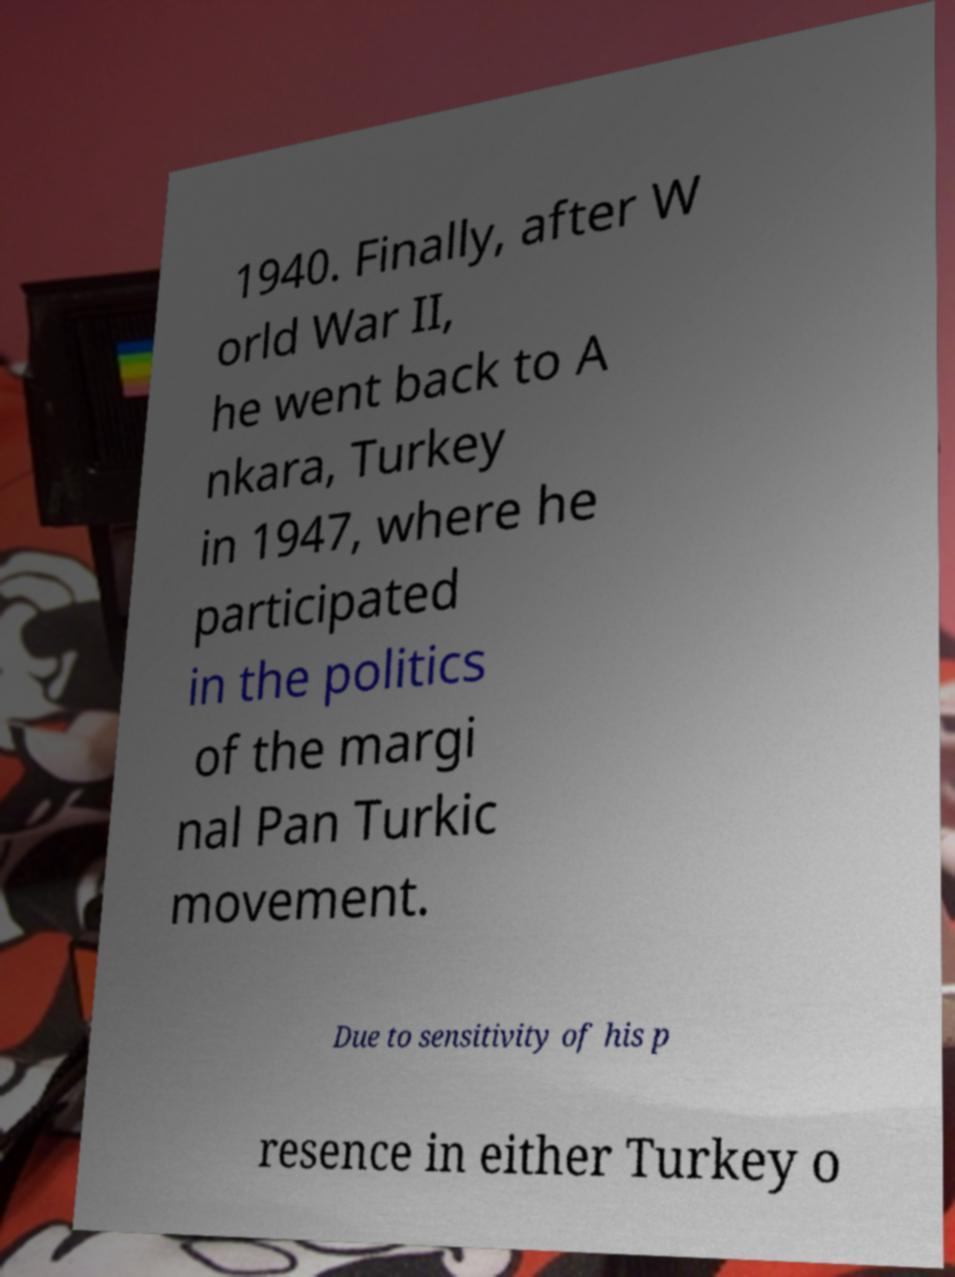Could you assist in decoding the text presented in this image and type it out clearly? 1940. Finally, after W orld War II, he went back to A nkara, Turkey in 1947, where he participated in the politics of the margi nal Pan Turkic movement. Due to sensitivity of his p resence in either Turkey o 